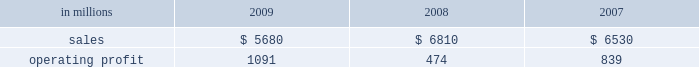Mill in the fourth quarter of 2008 .
This compares with 635000 tons of total downtime in 2008 of which 305000 tons were lack-of-order downtime .
Printing papers in millions 2009 2008 2007 .
North american printing papers net sales in 2009 were $ 2.8 billion compared with $ 3.4 billion in 2008 and $ 3.5 billion in 2007 .
Operating earnings in 2009 were $ 746 million ( $ 307 million excluding alter- native fuel mixture credits and plant closure costs ) compared with $ 405 million ( $ 435 million excluding shutdown costs for a paper machine ) in 2008 and $ 415 million in 2007 .
Sales volumes decreased sig- nificantly in 2009 compared with 2008 reflecting weak customer demand and reduced production capacity resulting from the shutdown of a paper machine at the franklin mill in december 2008 and the conversion of the bastrop mill to pulp production in june 2008 .
Average sales price realizations were lower reflecting slight declines for uncoated freesheet paper in domestic markets and significant declines in export markets .
Margins were also unfavorably affected by a higher proportion of shipments to lower-margin export markets .
Input costs , however , were favorable due to lower wood and chemical costs and sig- nificantly lower energy costs .
Freight costs were also lower .
Planned maintenance downtime costs in 2009 were comparable with 2008 .
Operating costs were favorable , reflecting cost control efforts and strong machine performance .
Lack-of-order downtime increased to 525000 tons in 2009 , including 120000 tons related to the shutdown of a paper machine at our franklin mill in the 2008 fourth quarter , from 135000 tons in 2008 .
Operating earnings in 2009 included $ 671 million of alternative fuel mixture cred- its , $ 223 million of costs associated with the shutdown of our franklin mill and $ 9 million of other shutdown costs , while operating earnings in 2008 included $ 30 million of costs for the shutdown of a paper machine at our franklin mill .
Looking ahead to 2010 , first-quarter sales volumes are expected to increase slightly from fourth-quarter 2009 levels .
Average sales price realizations should be higher , reflecting the full-quarter impact of sales price increases announced in the fourth quarter for converting and envelope grades of uncoated free- sheet paper and an increase in prices to export markets .
However , input costs for wood , energy and chemicals are expected to continue to increase .
Planned maintenance downtime costs should be lower and operating costs should be favorable .
Brazil ian papers net sales for 2009 of $ 960 mil- lion increased from $ 950 million in 2008 and $ 850 million in 2007 .
Operating profits for 2009 were $ 112 million compared with $ 186 million in 2008 and $ 174 million in 2007 .
Sales volumes increased in 2009 compared with 2008 for both paper and pulp reflect- ing higher export shipments .
Average sales price realizations were lower due to strong competitive pressures in the brazilian domestic market in the second half of the year , lower export prices and unfavorable foreign exchange rates .
Margins were unfavorably affected by a higher proportion of lower margin export sales .
Input costs for wood and chem- icals were favorable , but these benefits were partially offset by higher energy costs .
Planned maintenance downtime costs were lower , and operating costs were also favorable .
Earnings in 2009 were adversely impacted by unfavorable foreign exchange effects .
Entering 2010 , sales volumes are expected to be seasonally lower compared with the fourth quarter of 2009 .
Profit margins are expected to be slightly higher reflecting a more favorable geographic sales mix and improving sales price realizations in export markets , partially offset by higher planned main- tenance outage costs .
European papers net sales in 2009 were $ 1.3 bil- lion compared with $ 1.7 billion in 2008 and $ 1.5 bil- lion in 2007 .
Operating profits in 2009 of $ 92 million ( $ 115 million excluding expenses associated with the closure of the inverurie mill ) compared with $ 39 mil- lion ( $ 146 million excluding a charge to reduce the carrying value of the fixed assets at the inverurie , scotland mill to their estimated realizable value ) in 2008 and $ 171 million in 2007 .
Sales volumes in 2009 were lower than in 2008 primarily due to reduced sales of uncoated freesheet paper following the closure of the inverurie mill in 2009 .
Average sales price realizations decreased significantly in 2009 across most of western europe , but margins increased in poland and russia reflecting the effect of local currency devaluations .
Input costs were favorable as lower wood costs , particularly in russia , were only partially offset by higher energy costs in poland and higher chemical costs .
Planned main- tenance downtime costs were higher in 2009 than in 2008 , while manufacturing operating costs were lower .
Operating profits in 2009 also reflect favorable foreign exchange impacts .
Looking ahead to 2010 , sales volumes are expected to decline from strong 2009 fourth-quarter levels despite solid customer demand .
Average sales price realizations are expected to increase over the quar- ter , primarily in eastern europe , as price increases .
What is the variation observed in the value of operating expenses and other costs concerning the activities during 2008 and 2009? 
Rationale: it is the difference between the values of operating costs expenses of each year .
Computations: ((6810 - 474) - (5680 - 1091))
Answer: 1747.0. 